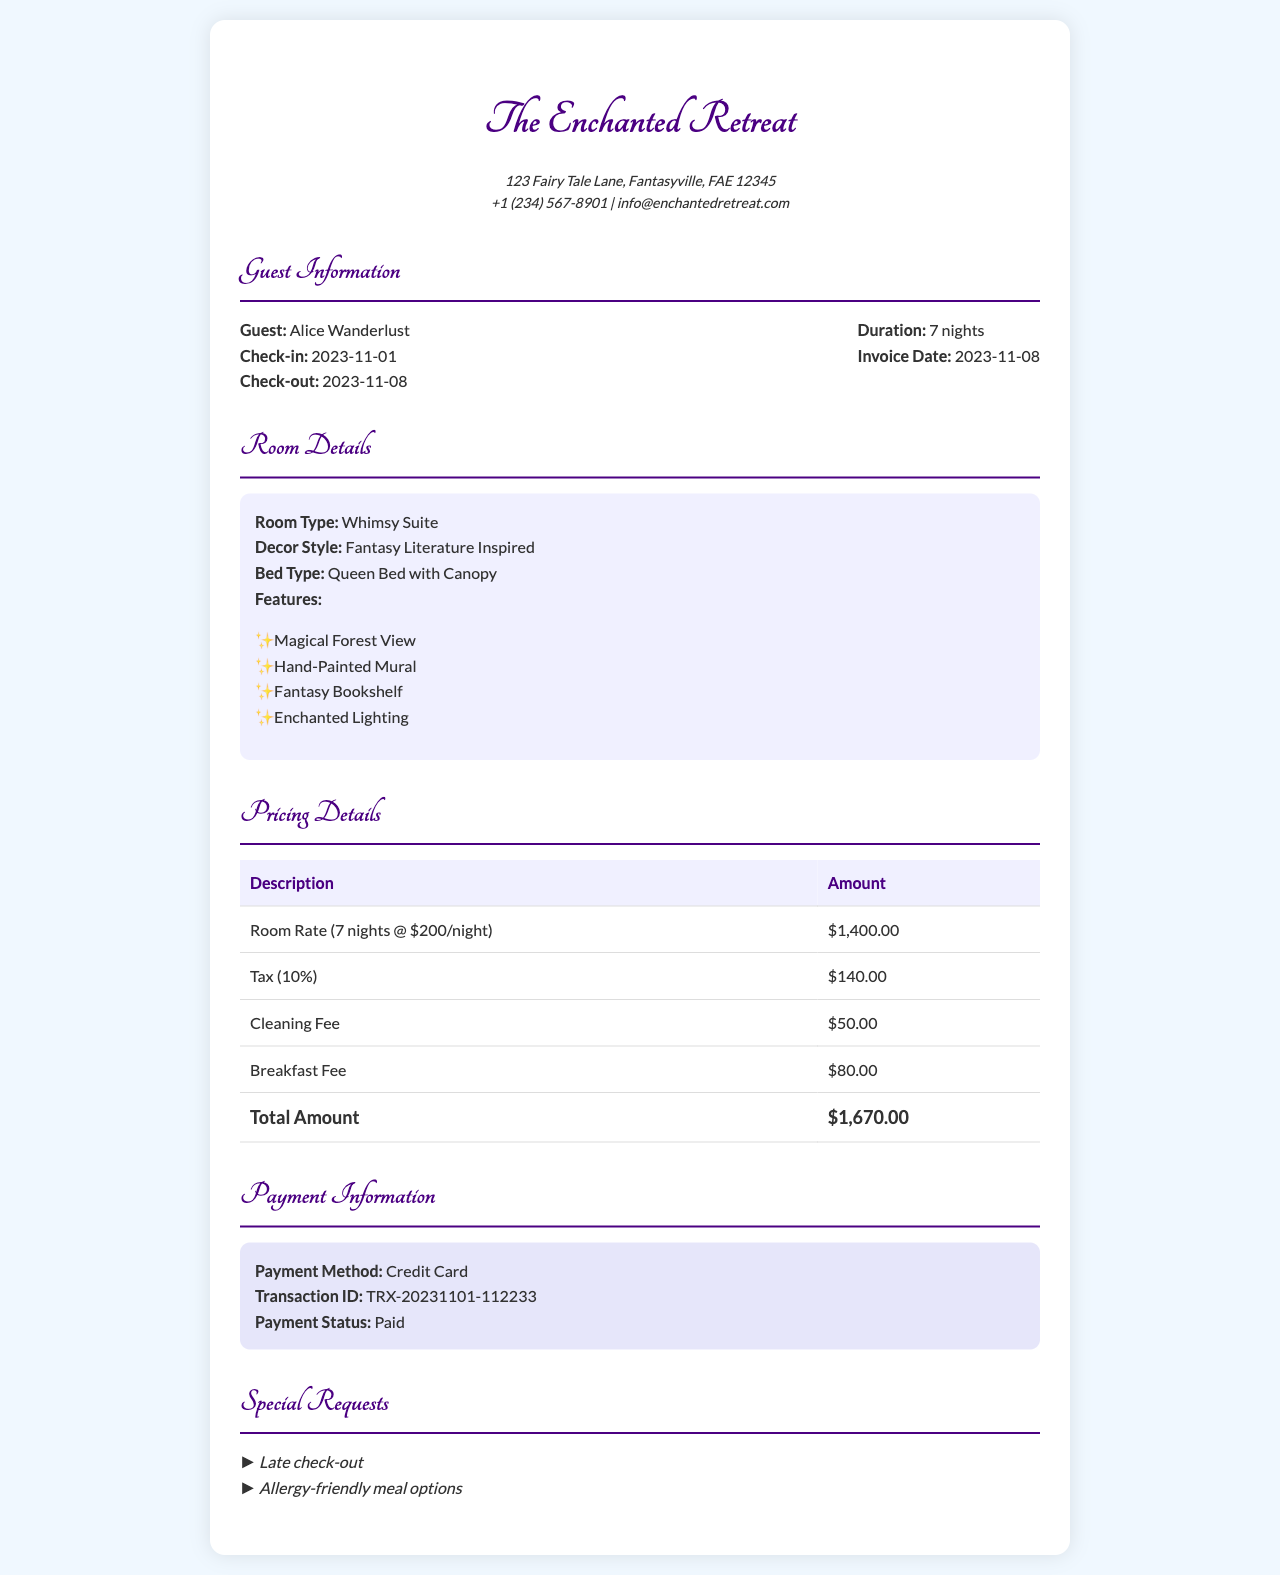what is the guest's name? The guest's name is provided in the guest information section of the document.
Answer: Alice Wanderlust what is the check-in date? The check-in date is listed in the guest information section of the document.
Answer: 2023-11-01 how many nights was the stay? The duration of the stay is mentioned in the guest information section of the document.
Answer: 7 nights what is the total amount due? The total amount is shown in the pricing details table at the end of the document.
Answer: $1,670.00 what payment method was used? The payment method is stated in the payment information section of the document.
Answer: Credit Card what cleaning fee is charged? The cleaning fee is included in the pricing details table of the document.
Answer: $50.00 which room type was booked? The room type is clearly outlined in the room details section of the document.
Answer: Whimsy Suite what special requests were made by the guest? The special requests are listed at the end of the document in their own section.
Answer: Late check-out, Allergy-friendly meal options what is the tax percentage applied? The tax percentage can be found in the pricing details section of the invoice.
Answer: 10% 